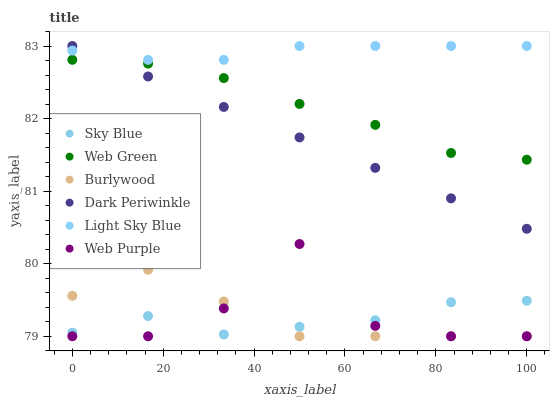Does Sky Blue have the minimum area under the curve?
Answer yes or no. Yes. Does Light Sky Blue have the maximum area under the curve?
Answer yes or no. Yes. Does Web Green have the minimum area under the curve?
Answer yes or no. No. Does Web Green have the maximum area under the curve?
Answer yes or no. No. Is Dark Periwinkle the smoothest?
Answer yes or no. Yes. Is Web Purple the roughest?
Answer yes or no. Yes. Is Web Green the smoothest?
Answer yes or no. No. Is Web Green the roughest?
Answer yes or no. No. Does Burlywood have the lowest value?
Answer yes or no. Yes. Does Web Green have the lowest value?
Answer yes or no. No. Does Dark Periwinkle have the highest value?
Answer yes or no. Yes. Does Web Green have the highest value?
Answer yes or no. No. Is Web Purple less than Dark Periwinkle?
Answer yes or no. Yes. Is Light Sky Blue greater than Web Purple?
Answer yes or no. Yes. Does Sky Blue intersect Burlywood?
Answer yes or no. Yes. Is Sky Blue less than Burlywood?
Answer yes or no. No. Is Sky Blue greater than Burlywood?
Answer yes or no. No. Does Web Purple intersect Dark Periwinkle?
Answer yes or no. No. 